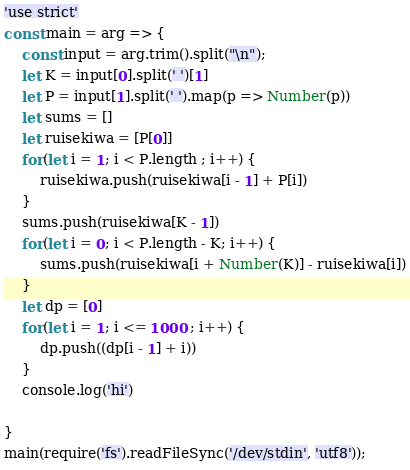Convert code to text. <code><loc_0><loc_0><loc_500><loc_500><_JavaScript_>'use strict'
const main = arg => {
	const input = arg.trim().split("\n");
	let K = input[0].split(' ')[1]
	let P = input[1].split(' ').map(p => Number(p))
	let sums = []
	let ruisekiwa = [P[0]]
	for(let i = 1; i < P.length ; i++) {
		ruisekiwa.push(ruisekiwa[i - 1] + P[i])
	}
	sums.push(ruisekiwa[K - 1])
	for(let i = 0; i < P.length - K; i++) {
		sums.push(ruisekiwa[i + Number(K)] - ruisekiwa[i])
	}
	let dp = [0]
	for(let i = 1; i <= 1000 ; i++) {
		dp.push((dp[i - 1] + i))
	}
    console.log('hi')
	
}   
main(require('fs').readFileSync('/dev/stdin', 'utf8'));</code> 